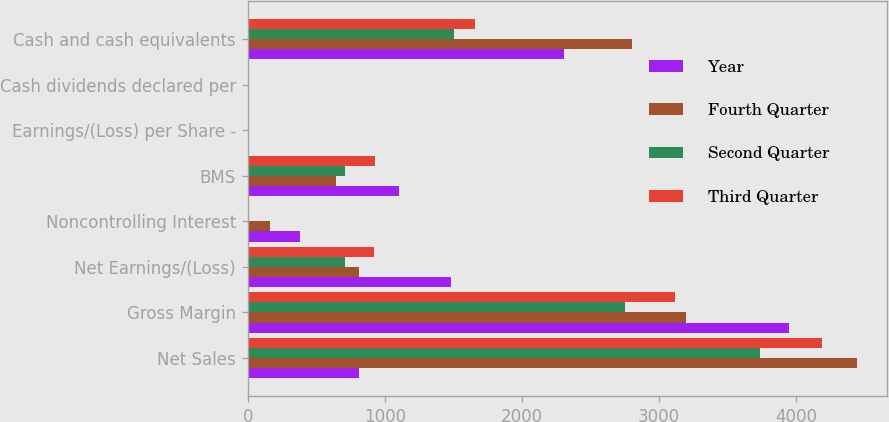<chart> <loc_0><loc_0><loc_500><loc_500><stacked_bar_chart><ecel><fcel>Net Sales<fcel>Gross Margin<fcel>Net Earnings/(Loss)<fcel>Noncontrolling Interest<fcel>BMS<fcel>Earnings/(Loss) per Share -<fcel>Cash dividends declared per<fcel>Cash and cash equivalents<nl><fcel>Year<fcel>808<fcel>3948<fcel>1482<fcel>381<fcel>1101<fcel>0.65<fcel>0.34<fcel>2307<nl><fcel>Fourth Quarter<fcel>4443<fcel>3198<fcel>808<fcel>163<fcel>645<fcel>0.38<fcel>0.34<fcel>2801<nl><fcel>Second Quarter<fcel>3736<fcel>2749<fcel>713<fcel>2<fcel>711<fcel>0.43<fcel>0.34<fcel>1503<nl><fcel>Third Quarter<fcel>4191<fcel>3116<fcel>924<fcel>1<fcel>925<fcel>0.56<fcel>0.35<fcel>1656<nl></chart> 